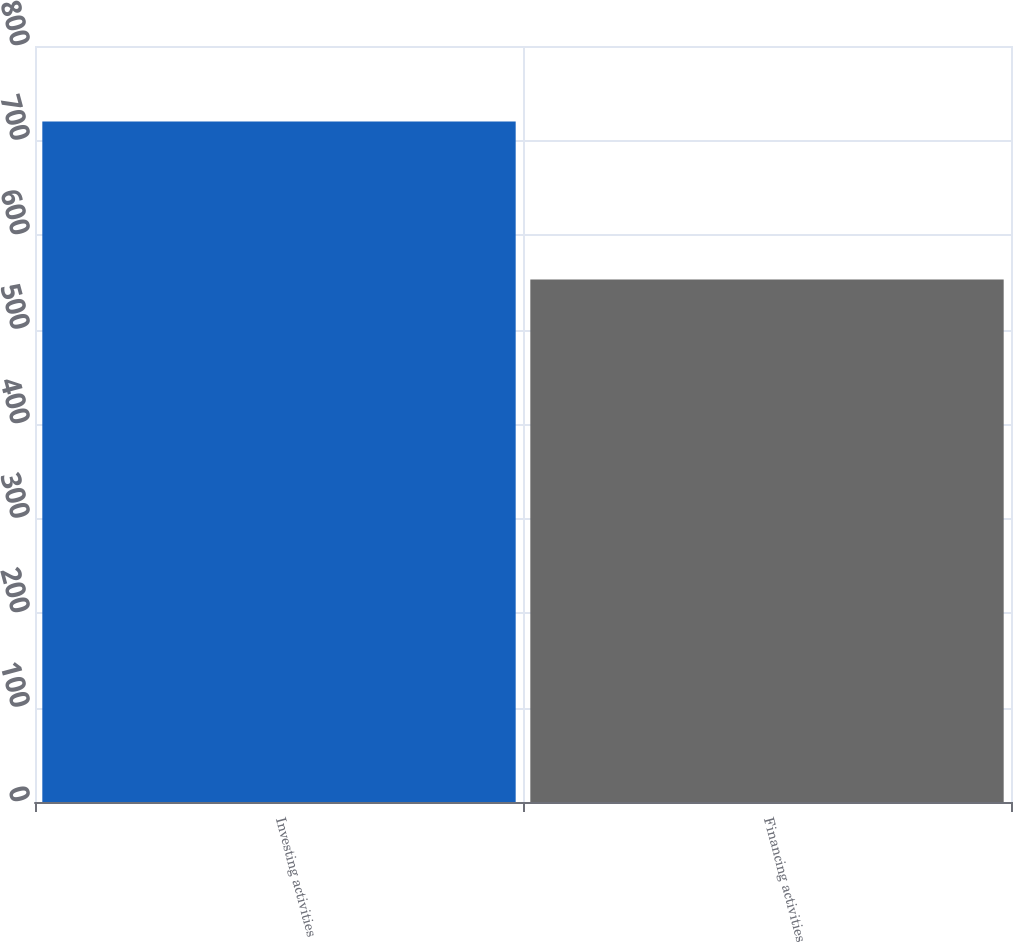Convert chart to OTSL. <chart><loc_0><loc_0><loc_500><loc_500><bar_chart><fcel>Investing activities<fcel>Financing activities<nl><fcel>720<fcel>553<nl></chart> 